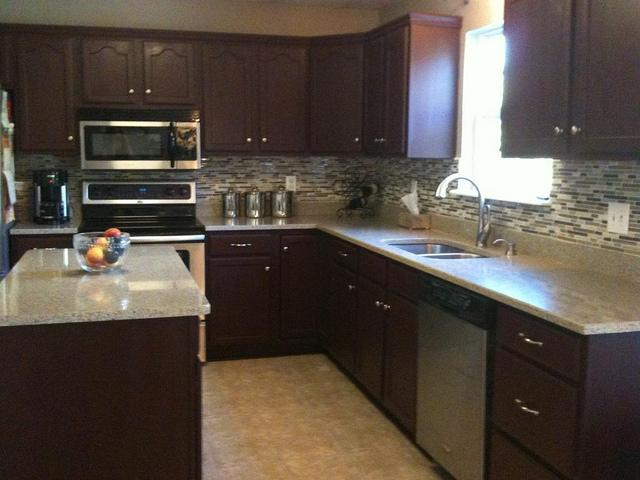The glare from the sun may interfere with a persons ability to do what while cooking? Please explain your reasoning. see. Someone who's blinded by the light might not be able to see. 